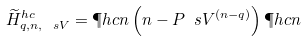Convert formula to latex. <formula><loc_0><loc_0><loc_500><loc_500>\widetilde { H } ^ { h c } _ { q , n , \ s V } = \P h c { n } \left ( n - P _ { \ } s V ^ { ( n - q ) } \right ) \P h c { n }</formula> 